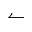<formula> <loc_0><loc_0><loc_500><loc_500>\leftharpoonup</formula> 